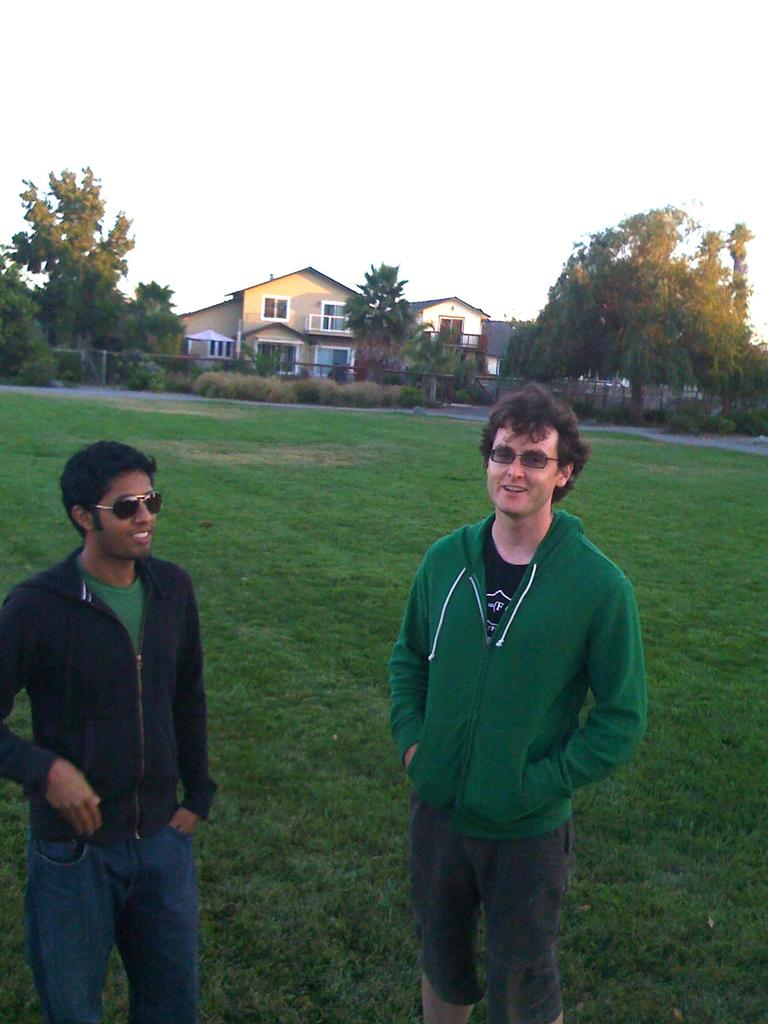How many people are in the image? There are two persons in the image. What are the persons wearing on their faces? The persons are wearing goggles. What position are the persons in? The persons are standing. What type of vegetation can be seen in the background of the image? There are trees in the background of the image. What type of structures are visible in the background of the image? There are buildings with windows in the background of the image. What part of the natural environment is visible in the background of the image? The sky is visible in the background of the image. What type of toothpaste is the person holding in the image? There is no toothpaste present in the image. What type of berry is the person eating in the image? There is no berry present in the image. 